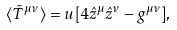Convert formula to latex. <formula><loc_0><loc_0><loc_500><loc_500>\langle \tilde { T } ^ { \mu \nu } \rangle = u [ 4 \hat { z } ^ { \mu } \hat { z } ^ { \nu } - g ^ { \mu \nu } ] ,</formula> 